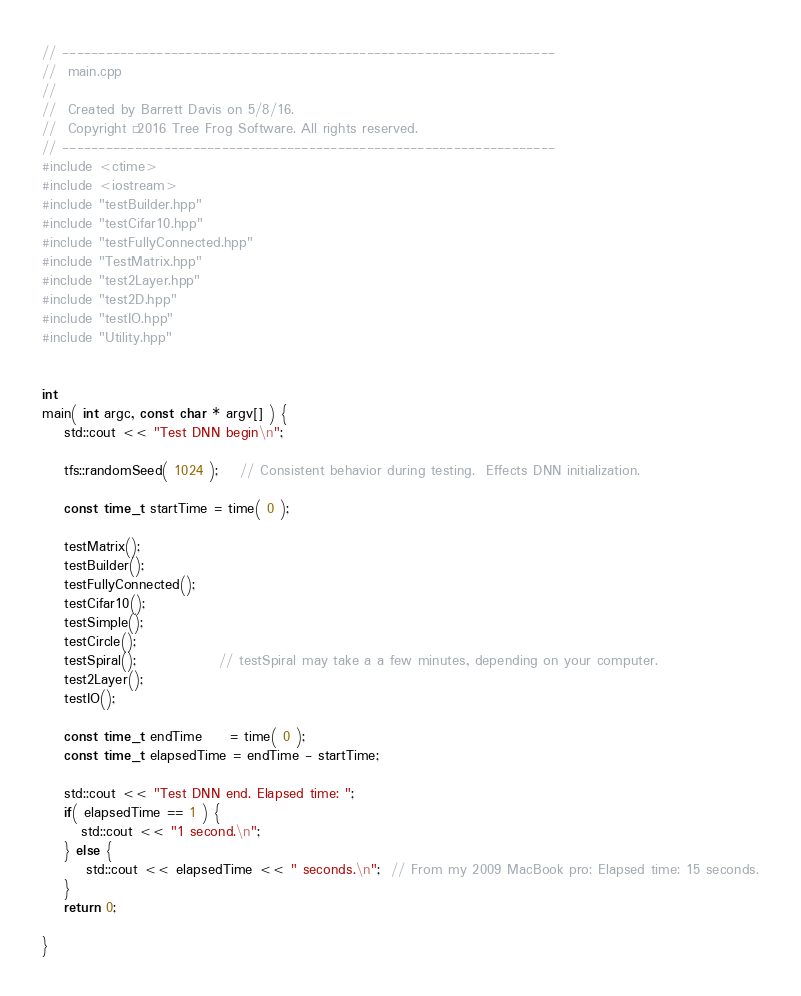Convert code to text. <code><loc_0><loc_0><loc_500><loc_500><_C++_>// --------------------------------------------------------------------
//  main.cpp
//
//  Created by Barrett Davis on 5/8/16.
//  Copyright © 2016 Tree Frog Software. All rights reserved.
// --------------------------------------------------------------------
#include <ctime>
#include <iostream>
#include "testBuilder.hpp"
#include "testCifar10.hpp"
#include "testFullyConnected.hpp"
#include "TestMatrix.hpp"
#include "test2Layer.hpp"
#include "test2D.hpp"
#include "testIO.hpp"
#include "Utility.hpp"


int
main( int argc, const char * argv[] ) {
    std::cout << "Test DNN begin\n";
    
    tfs::randomSeed( 1024 );    // Consistent behavior during testing.  Effects DNN initialization.

    const time_t startTime = time( 0 );
    
    testMatrix();
    testBuilder();
    testFullyConnected();
    testCifar10();
    testSimple();
    testCircle();
    testSpiral();               // testSpiral may take a a few minutes, depending on your computer.
    test2Layer();
    testIO();
    
    const time_t endTime     = time( 0 );
    const time_t elapsedTime = endTime - startTime;
    
    std::cout << "Test DNN end. Elapsed time: ";
    if( elapsedTime == 1 ) {
       std::cout << "1 second.\n";
    } else {
        std::cout << elapsedTime << " seconds.\n";  // From my 2009 MacBook pro: Elapsed time: 15 seconds.
    }
    return 0;
    
}


</code> 